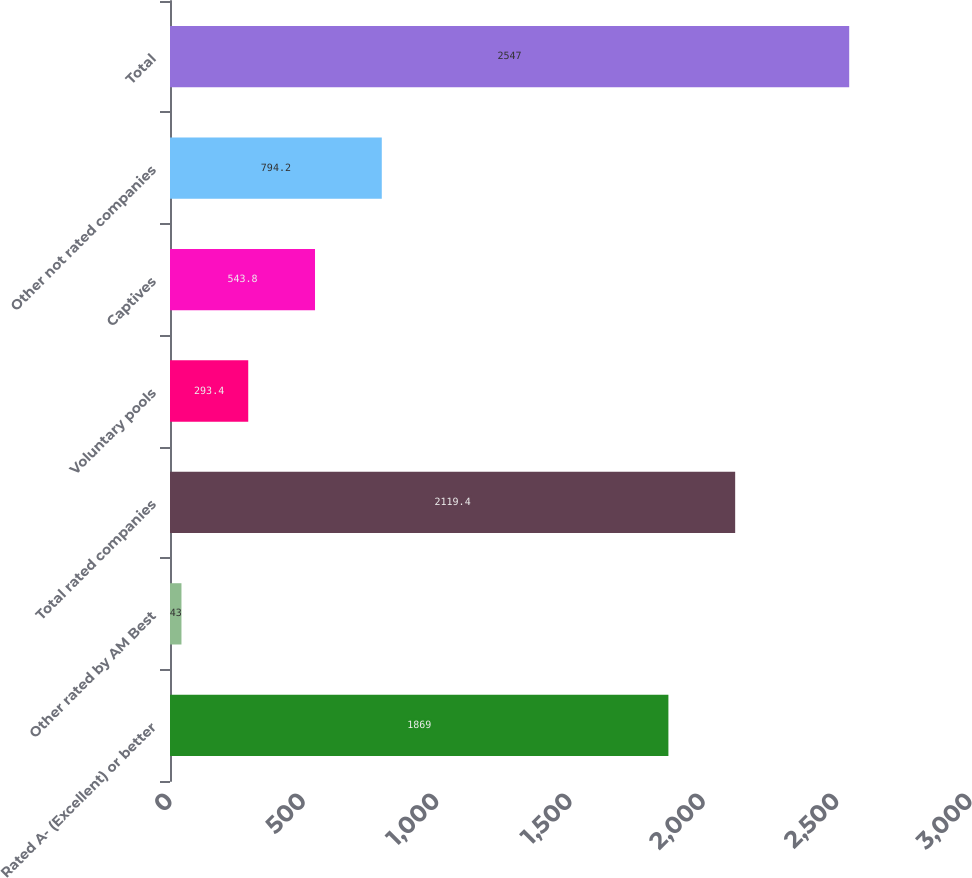<chart> <loc_0><loc_0><loc_500><loc_500><bar_chart><fcel>Rated A- (Excellent) or better<fcel>Other rated by AM Best<fcel>Total rated companies<fcel>Voluntary pools<fcel>Captives<fcel>Other not rated companies<fcel>Total<nl><fcel>1869<fcel>43<fcel>2119.4<fcel>293.4<fcel>543.8<fcel>794.2<fcel>2547<nl></chart> 